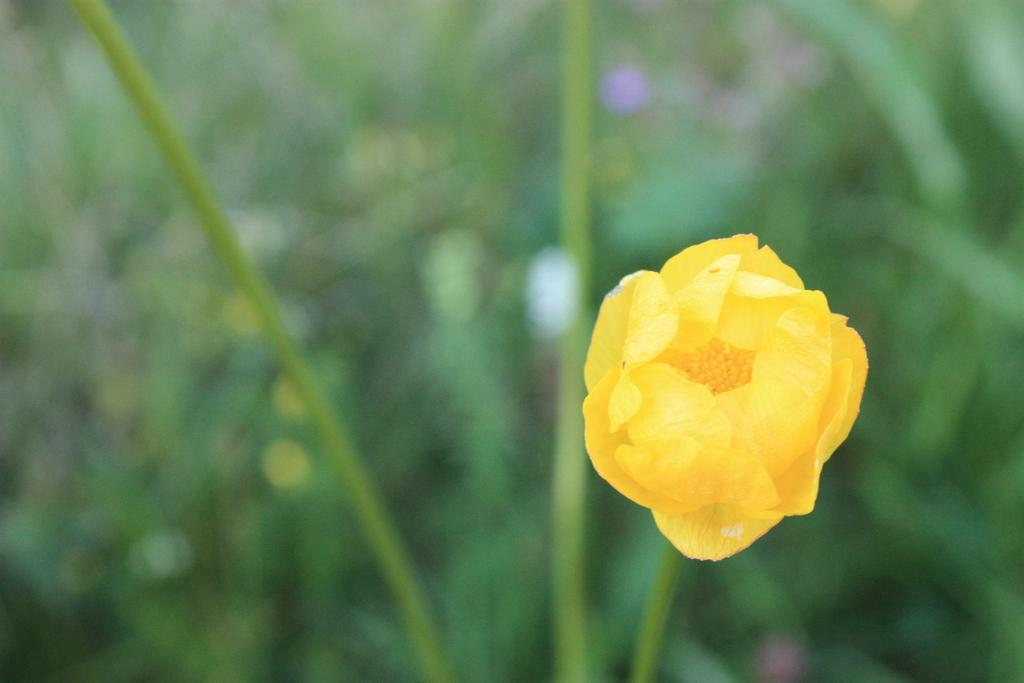What type of flower is in the image? There is a yellow flower in the image. Can you describe the background of the image? The background of the image is blurred. Is the person wearing a hat running in the image? There is no person or hat present in the image, so this question cannot be answered. 